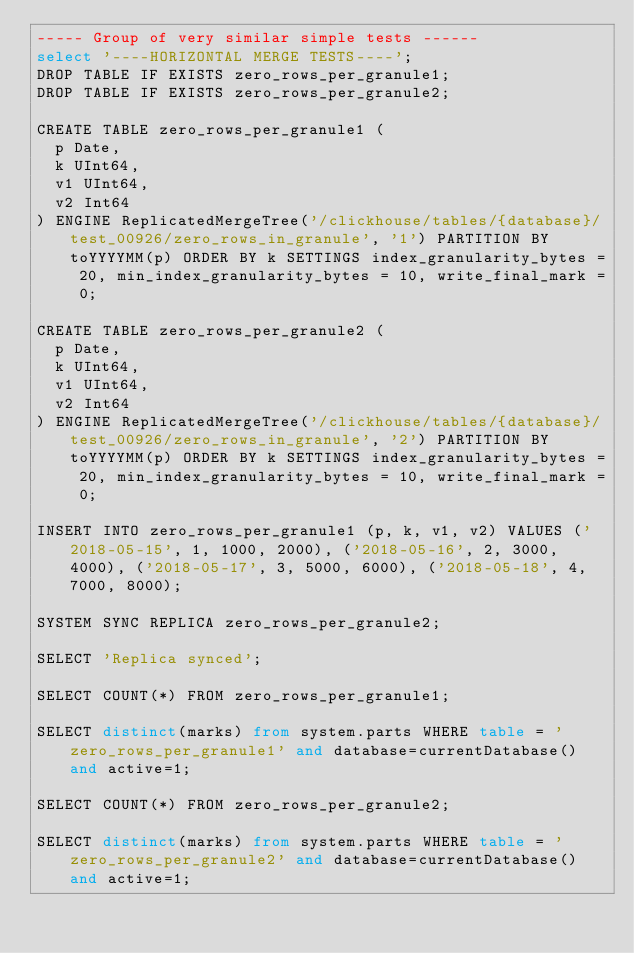Convert code to text. <code><loc_0><loc_0><loc_500><loc_500><_SQL_>----- Group of very similar simple tests ------
select '----HORIZONTAL MERGE TESTS----';
DROP TABLE IF EXISTS zero_rows_per_granule1;
DROP TABLE IF EXISTS zero_rows_per_granule2;

CREATE TABLE zero_rows_per_granule1 (
  p Date,
  k UInt64,
  v1 UInt64,
  v2 Int64
) ENGINE ReplicatedMergeTree('/clickhouse/tables/{database}/test_00926/zero_rows_in_granule', '1') PARTITION BY toYYYYMM(p) ORDER BY k SETTINGS index_granularity_bytes = 20, min_index_granularity_bytes = 10, write_final_mark = 0;

CREATE TABLE zero_rows_per_granule2 (
  p Date,
  k UInt64,
  v1 UInt64,
  v2 Int64
) ENGINE ReplicatedMergeTree('/clickhouse/tables/{database}/test_00926/zero_rows_in_granule', '2') PARTITION BY toYYYYMM(p) ORDER BY k SETTINGS index_granularity_bytes = 20, min_index_granularity_bytes = 10, write_final_mark = 0;

INSERT INTO zero_rows_per_granule1 (p, k, v1, v2) VALUES ('2018-05-15', 1, 1000, 2000), ('2018-05-16', 2, 3000, 4000), ('2018-05-17', 3, 5000, 6000), ('2018-05-18', 4, 7000, 8000);

SYSTEM SYNC REPLICA zero_rows_per_granule2;

SELECT 'Replica synced';

SELECT COUNT(*) FROM zero_rows_per_granule1;

SELECT distinct(marks) from system.parts WHERE table = 'zero_rows_per_granule1' and database=currentDatabase() and active=1;

SELECT COUNT(*) FROM zero_rows_per_granule2;

SELECT distinct(marks) from system.parts WHERE table = 'zero_rows_per_granule2' and database=currentDatabase() and active=1;
</code> 